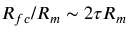<formula> <loc_0><loc_0><loc_500><loc_500>R _ { f c } / R _ { m } \sim 2 \tau R _ { m }</formula> 